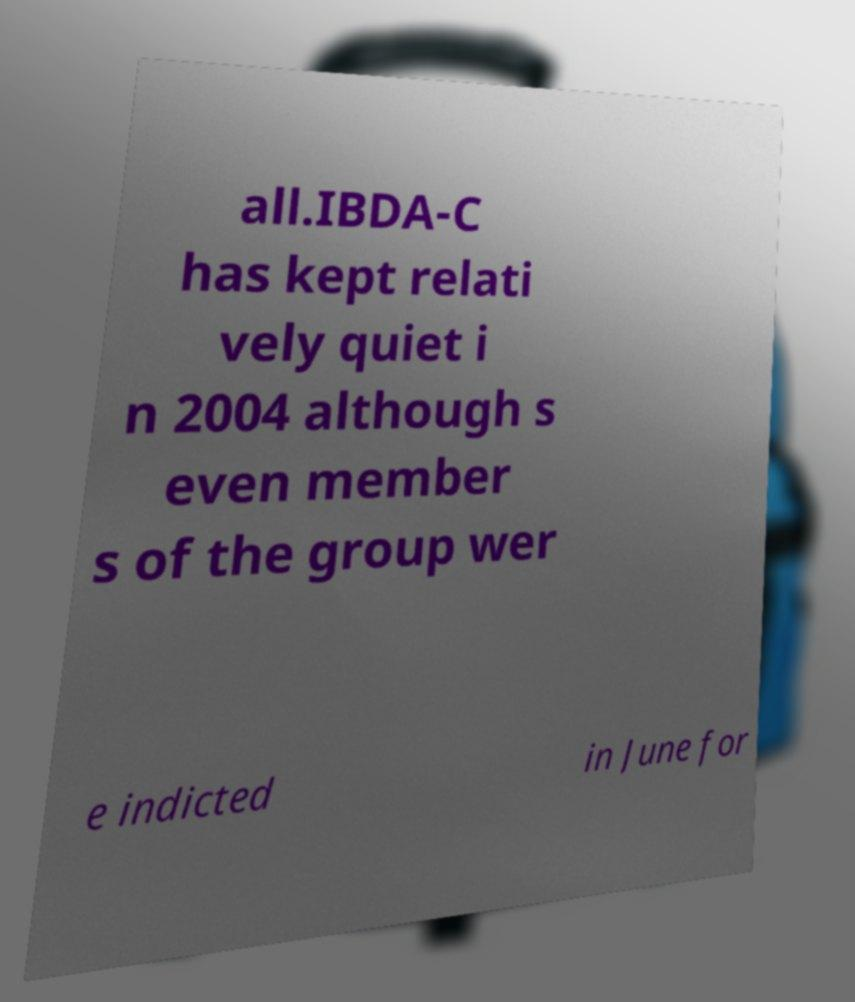I need the written content from this picture converted into text. Can you do that? all.IBDA-C has kept relati vely quiet i n 2004 although s even member s of the group wer e indicted in June for 